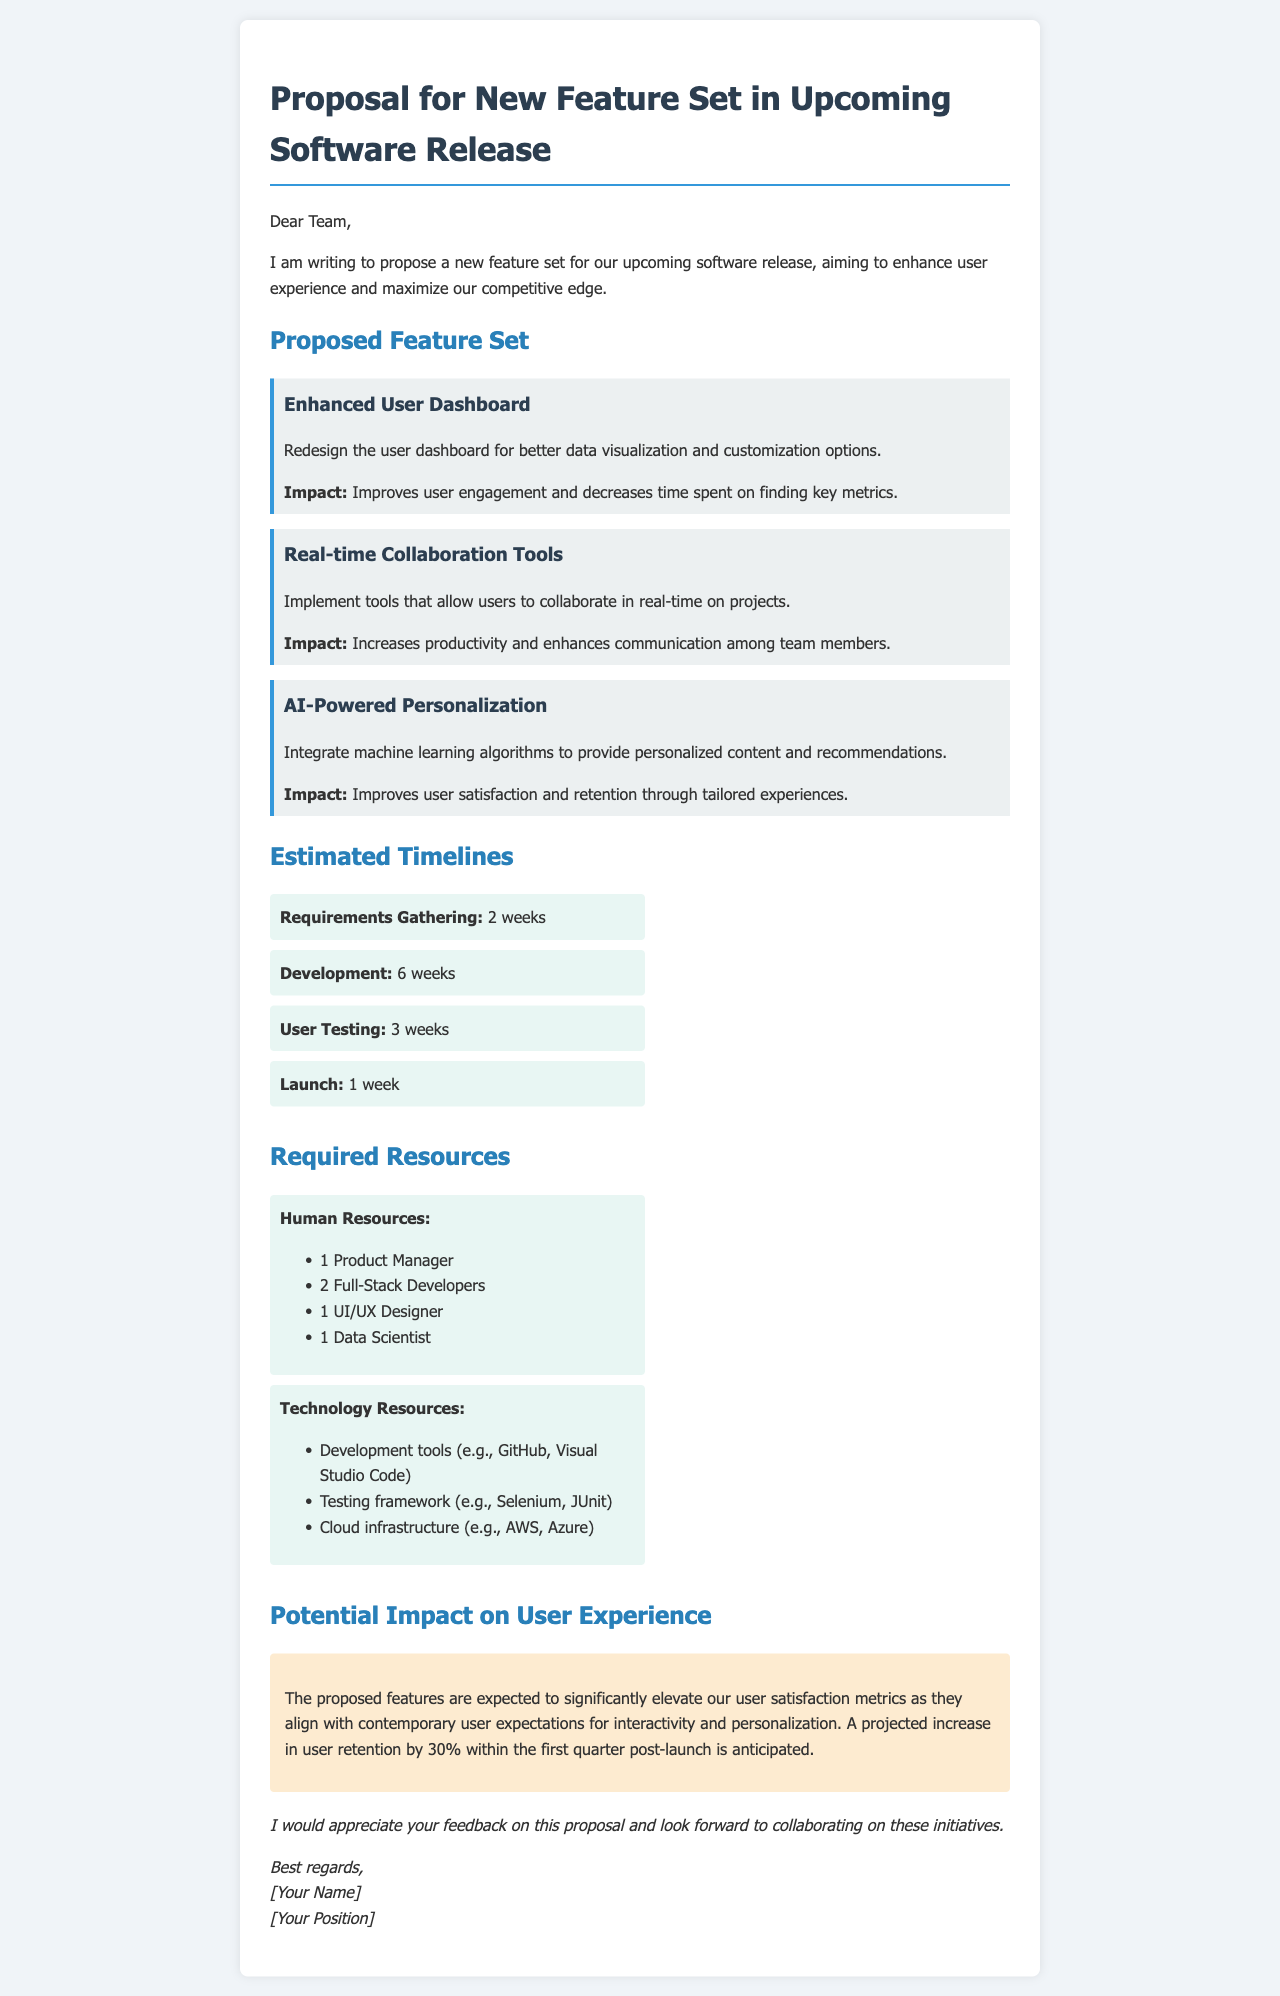what is the proposed feature related to user engagement? The proposal includes an "Enhanced User Dashboard" aimed at improving user engagement.
Answer: Enhanced User Dashboard how many full-stack developers are required? The document lists the required human resources, stating 2 Full-Stack Developers are needed.
Answer: 2 Full-Stack Developers what is the duration of the user testing phase? The timeline section indicates that user testing will last for 3 weeks.
Answer: 3 weeks what is the expected increase in user retention? The document projects a 30% increase in user retention within the first quarter post-launch.
Answer: 30% what technology resource is mentioned for testing? The resources section mentions "Selenium" as a testing framework in the technology resources.
Answer: Selenium what is the total estimated time from requirements gathering to launch? By adding the times from each phase: 2 weeks for gathering + 6 weeks for development + 3 weeks for testing + 1 week for launch equals a total of 12 weeks.
Answer: 12 weeks which role is not mentioned in the human resources section? The document does not mention a role for a Marketing Specialist among the listed human resources.
Answer: Marketing Specialist what is the color theme used for the document? The document features a color palette including shades of blue and gray, fostering a professional look.
Answer: Blue and gray who is the author of the proposal? The document concludes with "[Your Name]" as the placeholder for the author's name, indicating that it can be replaced with the actual name.
Answer: [Your Name] 